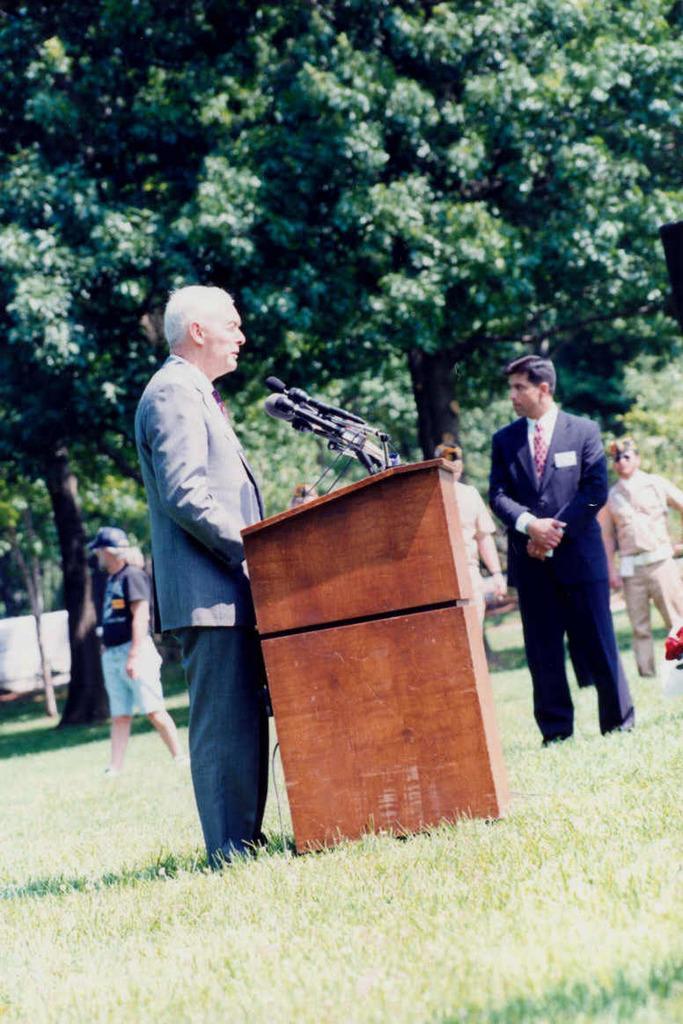In one or two sentences, can you explain what this image depicts? In the center of the image there is a person standing. There is a podium. At the bottom of the image there is grass. In the background of the image there are trees. 